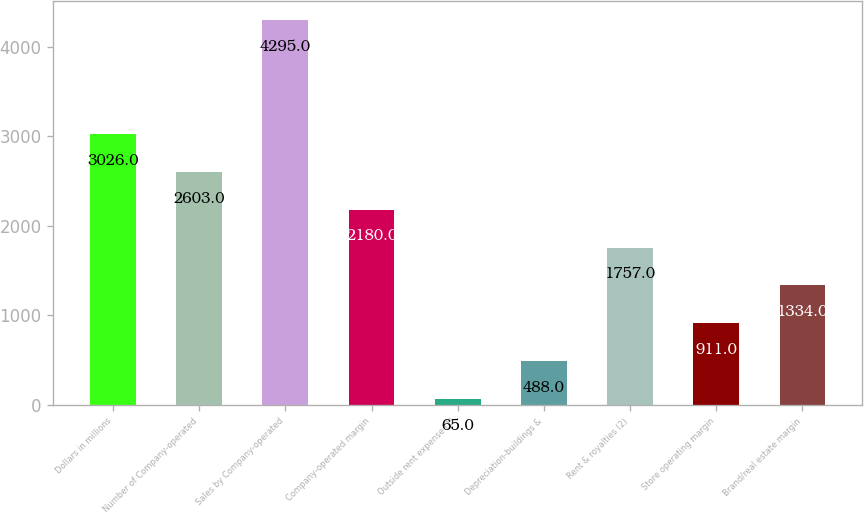Convert chart to OTSL. <chart><loc_0><loc_0><loc_500><loc_500><bar_chart><fcel>Dollars in millions<fcel>Number of Company-operated<fcel>Sales by Company-operated<fcel>Company-operated margin<fcel>Outside rent expense (1)<fcel>Depreciation-buildings &<fcel>Rent & royalties (2)<fcel>Store operating margin<fcel>Brand/real estate margin<nl><fcel>3026<fcel>2603<fcel>4295<fcel>2180<fcel>65<fcel>488<fcel>1757<fcel>911<fcel>1334<nl></chart> 